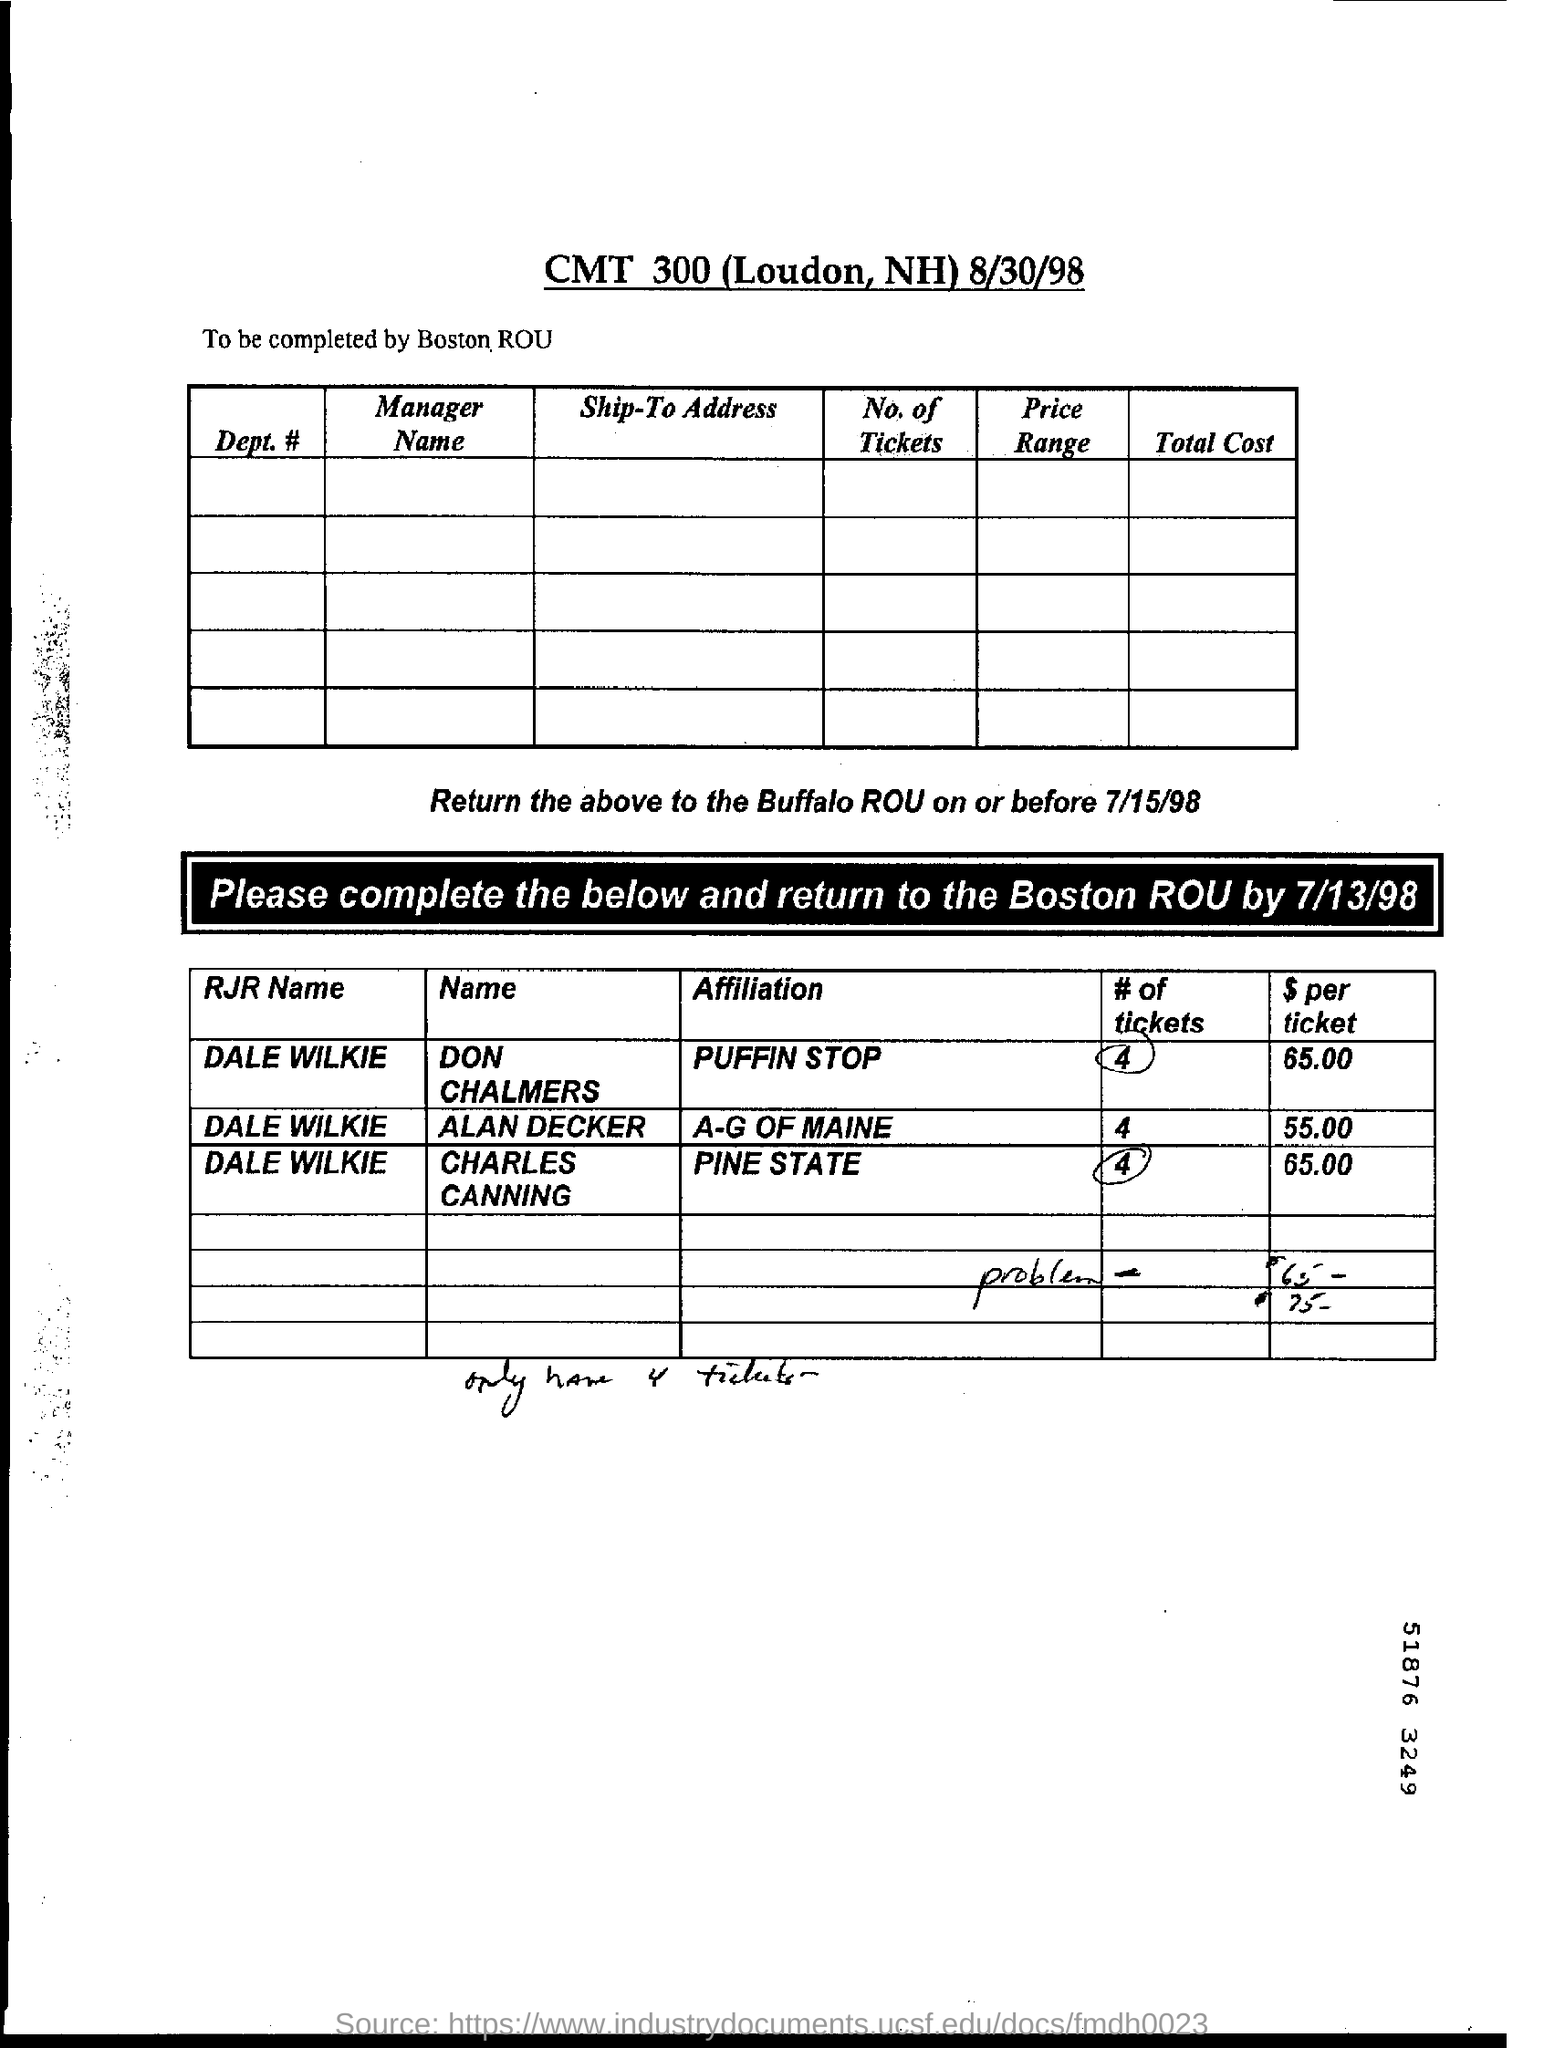What is the document title?
Your answer should be compact. CMT 300 (Loudon, NH) 8/30/98. Who should complete the form?
Your response must be concise. Boston Rou. What is the Affiliation of Don Chalmers?
Provide a succinct answer. PUFFIN STOP. What is the $ per ticket of A-G OF MAINE?
Provide a short and direct response. 55.00. 